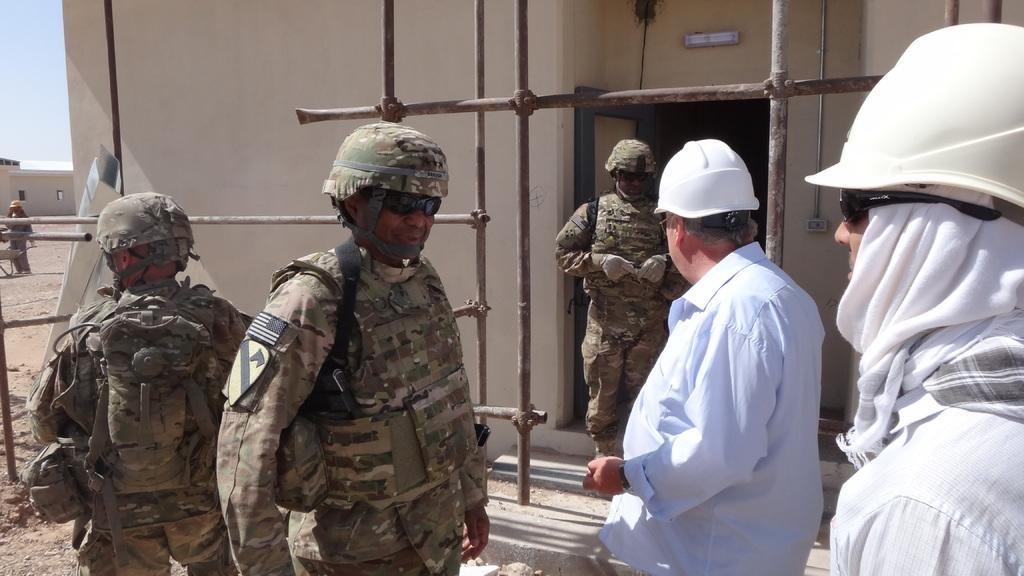In one or two sentences, can you explain what this image depicts? In this image there are a few men standing. Behind them there is a wall of a house. They are wearing helmets and sunglasses. In the top left there is the sky. 